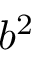Convert formula to latex. <formula><loc_0><loc_0><loc_500><loc_500>b ^ { 2 }</formula> 